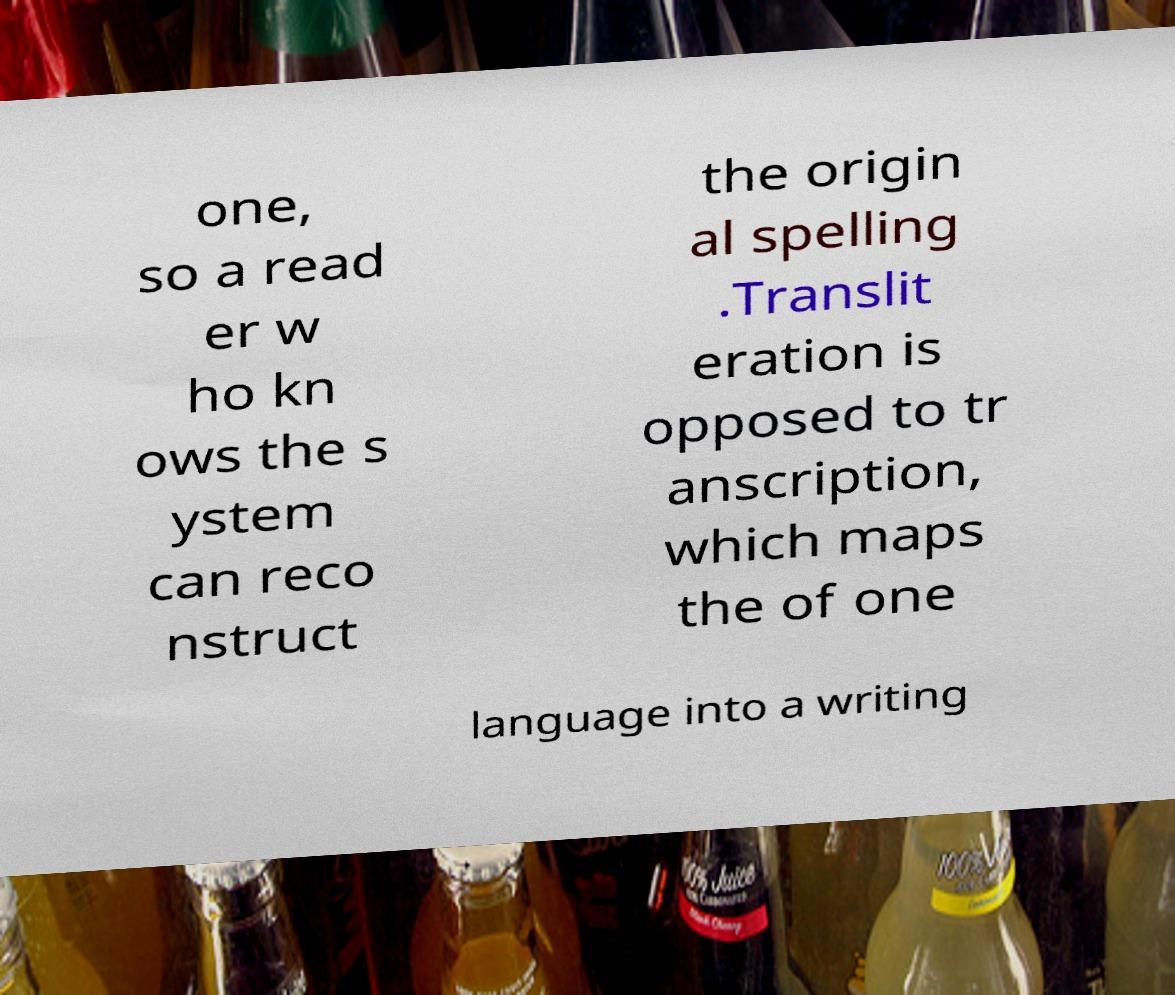Can you read and provide the text displayed in the image?This photo seems to have some interesting text. Can you extract and type it out for me? one, so a read er w ho kn ows the s ystem can reco nstruct the origin al spelling .Translit eration is opposed to tr anscription, which maps the of one language into a writing 